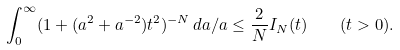Convert formula to latex. <formula><loc_0><loc_0><loc_500><loc_500>\int _ { 0 } ^ { \infty } ( 1 + ( a ^ { 2 } + a ^ { - 2 } ) t ^ { 2 } ) ^ { - N } \, d a / a \leq \frac { 2 } { N } I _ { N } ( t ) \quad ( t > 0 ) .</formula> 